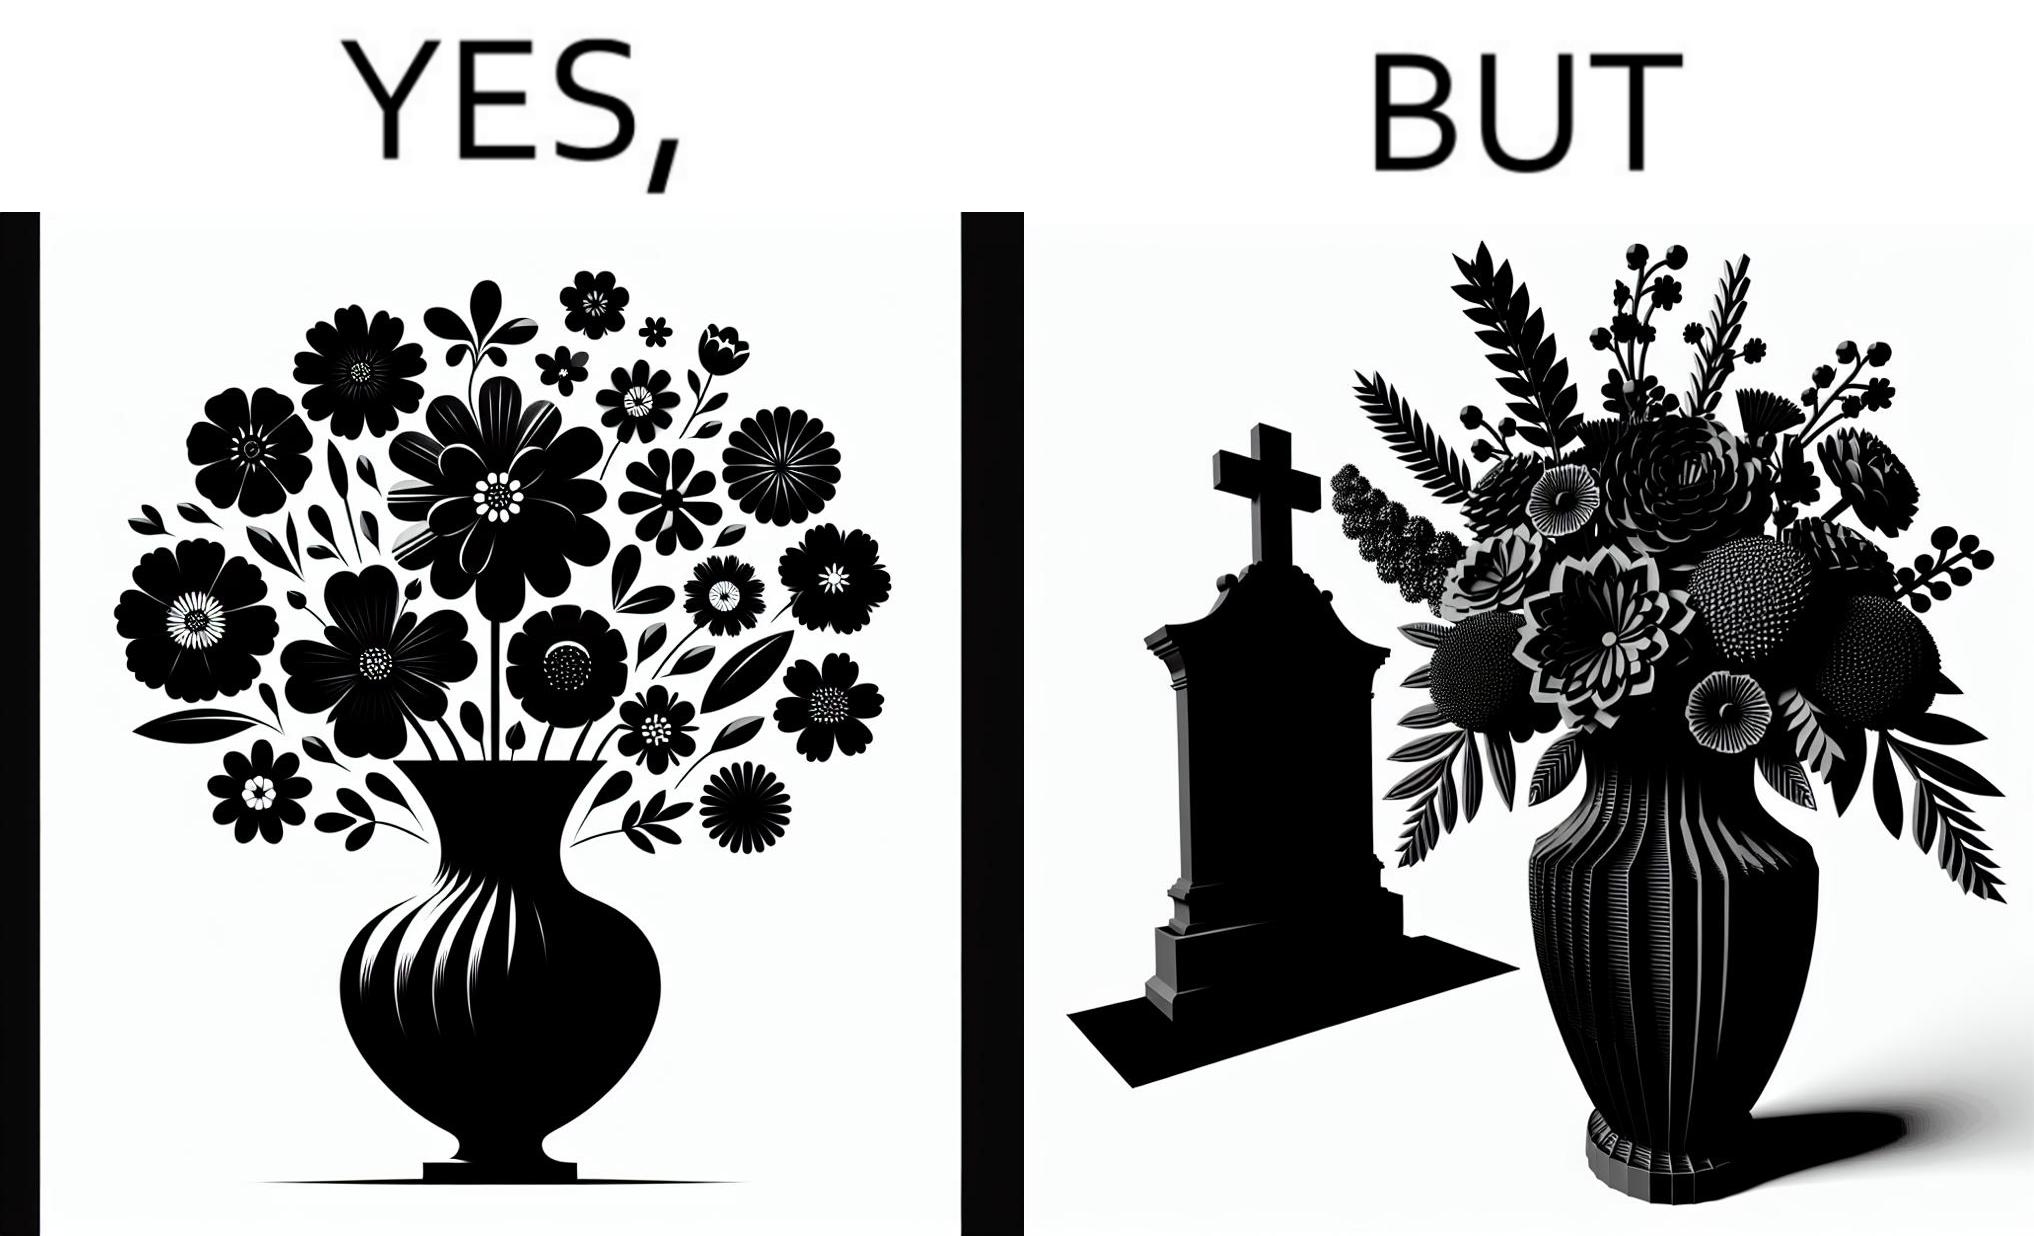Provide a description of this image. The image is ironic, because in the first image a vase full of different beautiful flowers is seen which spreads a feeling of positivity, cheerfulness etc., whereas in the second image when the same vase is put in front of a grave stone it produces a feeling of sorrow 